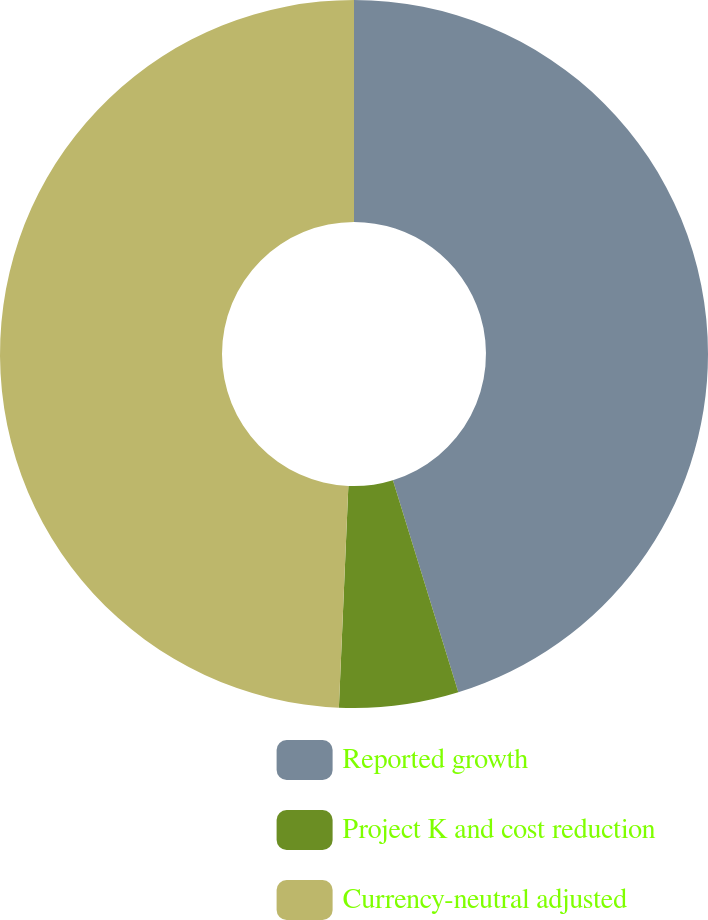Convert chart. <chart><loc_0><loc_0><loc_500><loc_500><pie_chart><fcel>Reported growth<fcel>Project K and cost reduction<fcel>Currency-neutral adjusted<nl><fcel>45.24%<fcel>5.44%<fcel>49.32%<nl></chart> 